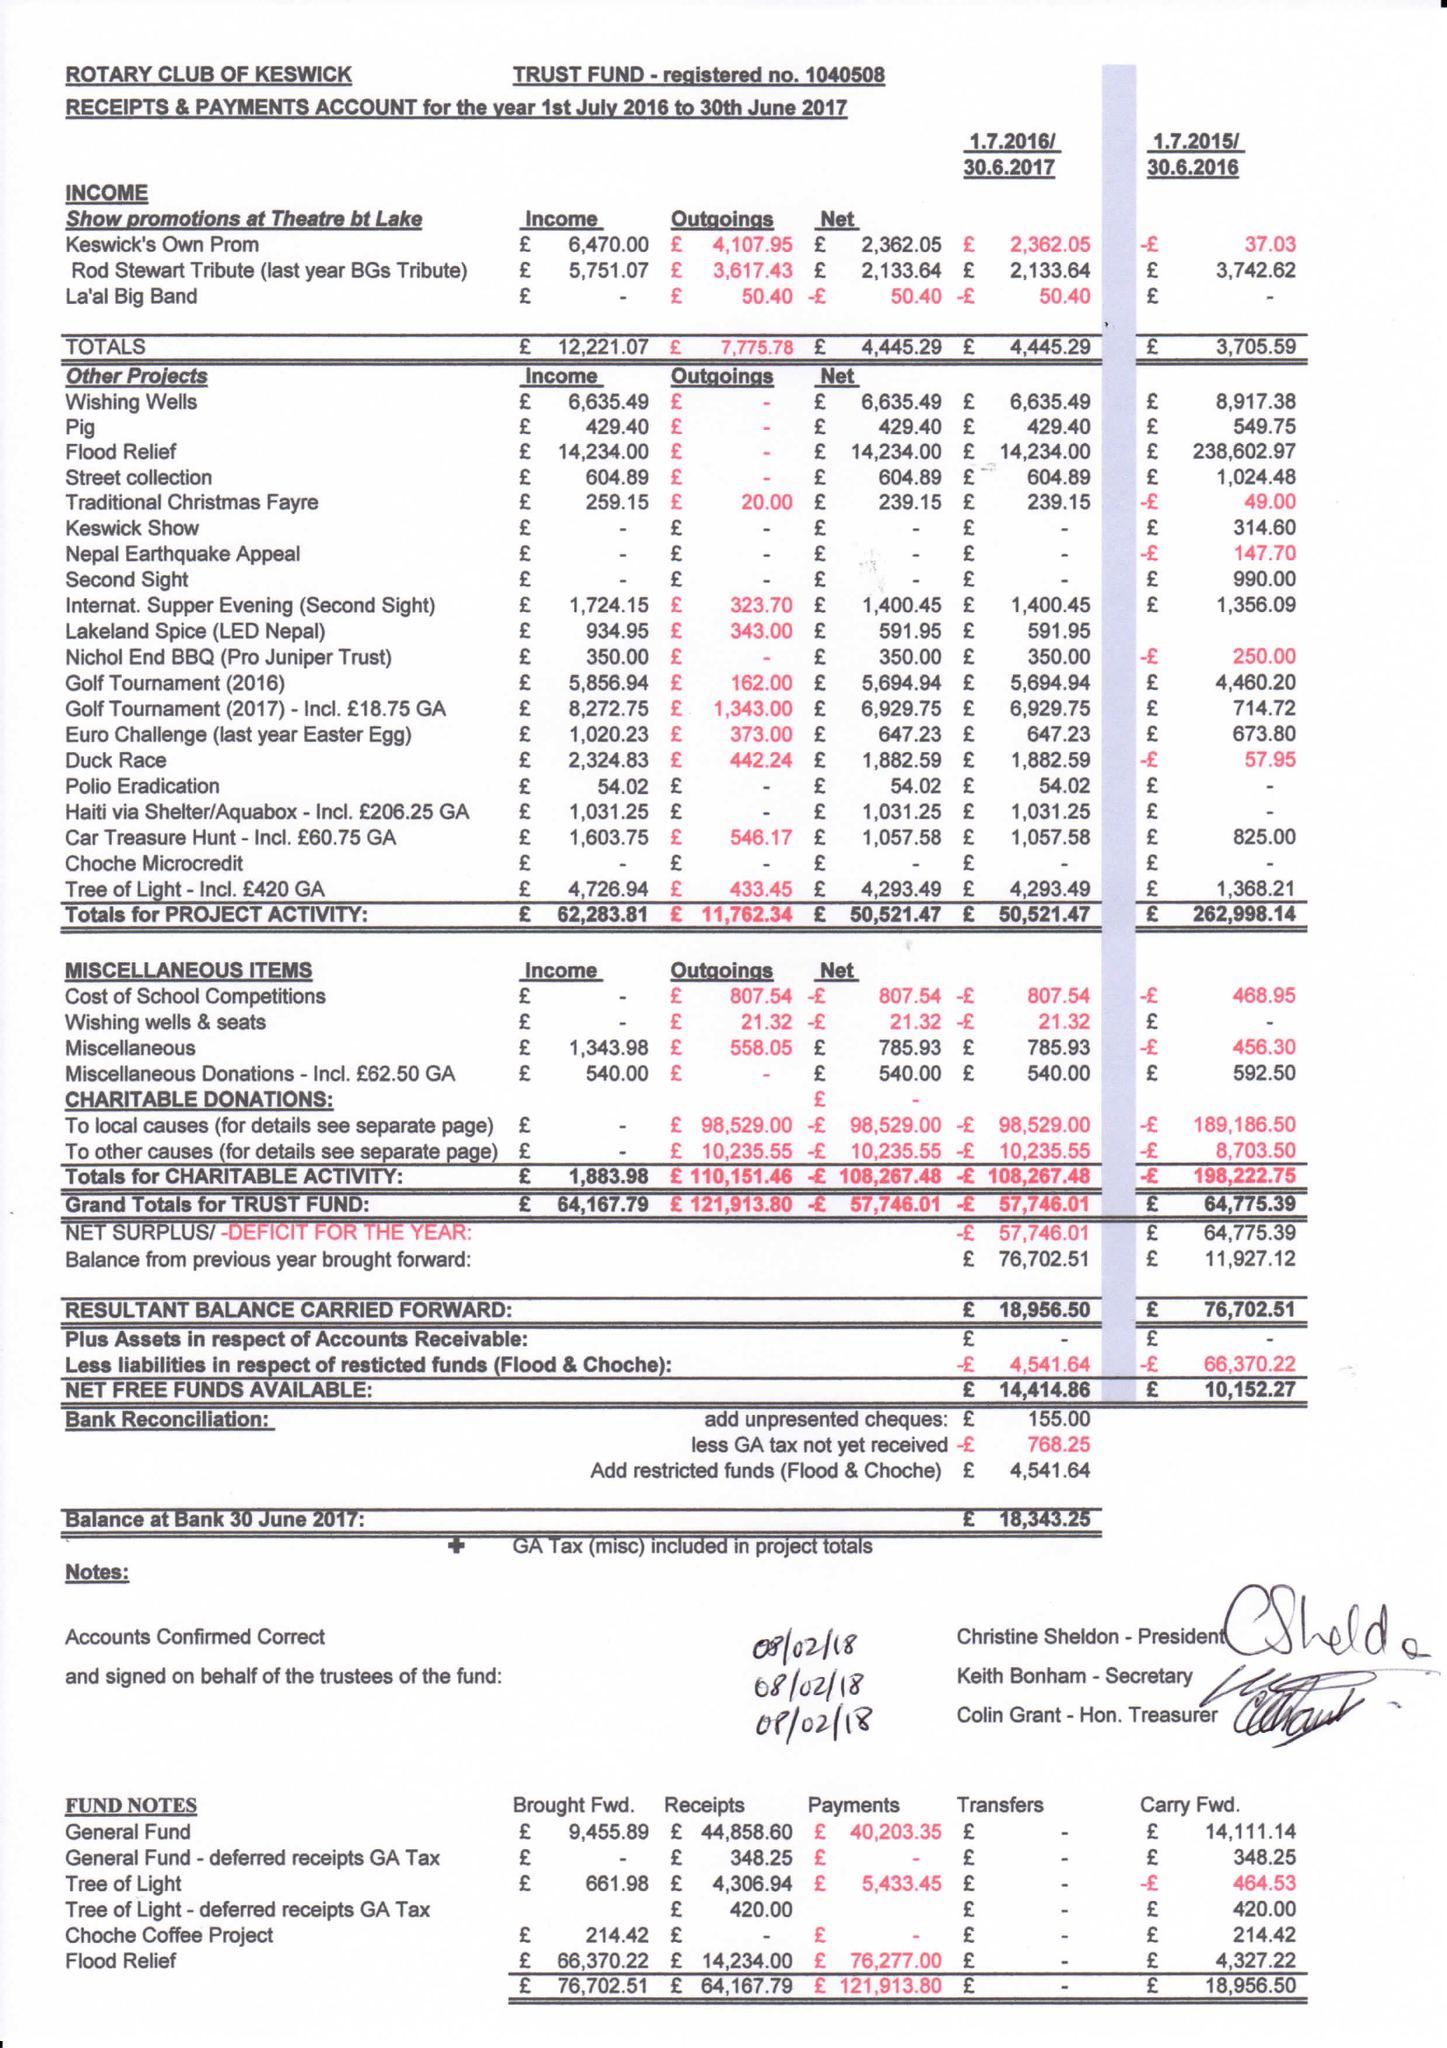What is the value for the address__postcode?
Answer the question using a single word or phrase. CA4 0PA 